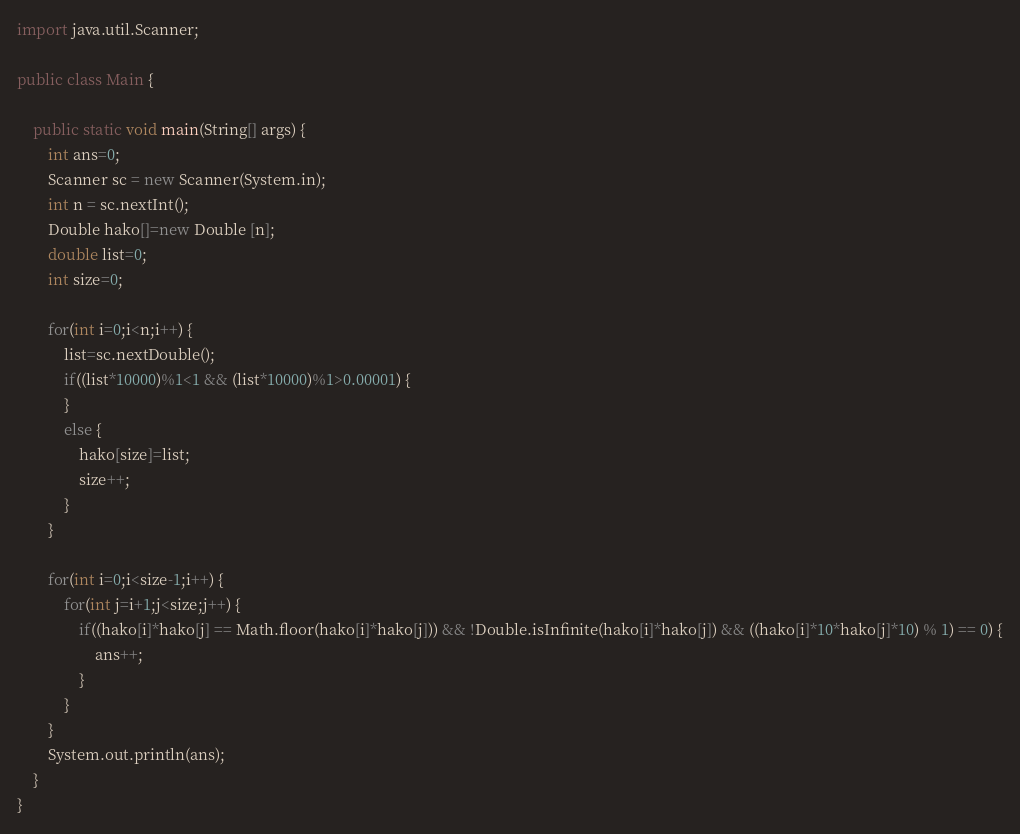<code> <loc_0><loc_0><loc_500><loc_500><_Java_>import java.util.Scanner;

public class Main {

	public static void main(String[] args) {
		int ans=0;
		Scanner sc = new Scanner(System.in);
		int n = sc.nextInt();
		Double hako[]=new Double [n];
		double list=0;
		int size=0;
		
		for(int i=0;i<n;i++) {
			list=sc.nextDouble();
			if((list*10000)%1<1 && (list*10000)%1>0.00001) {
			}
			else {
				hako[size]=list;
				size++;
			}
		}
		
		for(int i=0;i<size-1;i++) {
			for(int j=i+1;j<size;j++) {
				if((hako[i]*hako[j] == Math.floor(hako[i]*hako[j])) && !Double.isInfinite(hako[i]*hako[j]) && ((hako[i]*10*hako[j]*10) % 1) == 0) {
					ans++;
				}
			}
		}
		System.out.println(ans);
	}
}
</code> 